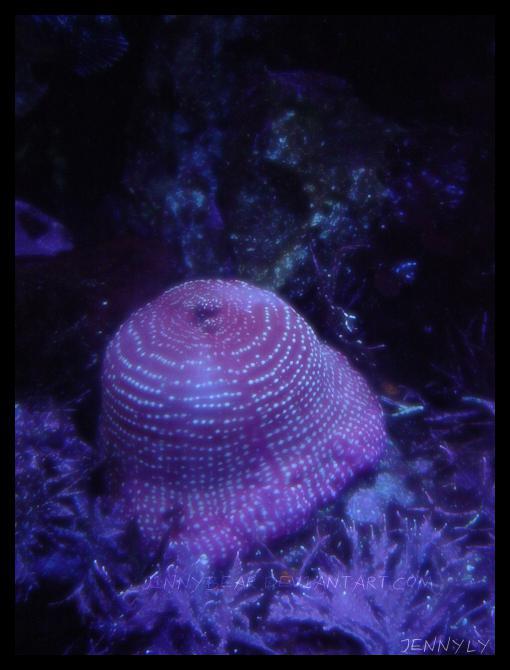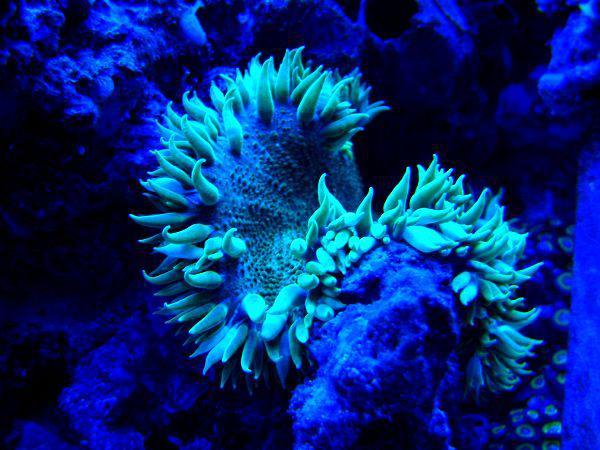The first image is the image on the left, the second image is the image on the right. For the images displayed, is the sentence "A fish is swimming in the sea plant in both the images." factually correct? Answer yes or no. No. The first image is the image on the left, the second image is the image on the right. Examine the images to the left and right. Is the description "Each image shows at least one clown fish swimming among anemone." accurate? Answer yes or no. No. 